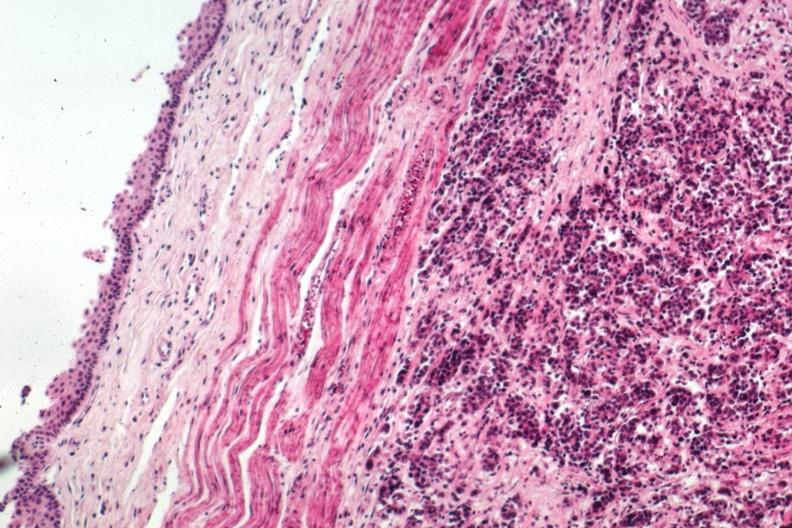what is present?
Answer the question using a single word or phrase. Gastrointestinal 